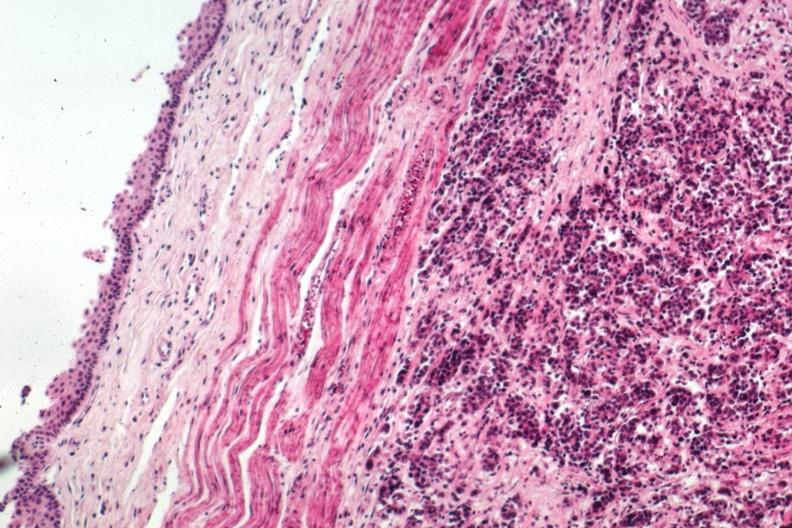what is present?
Answer the question using a single word or phrase. Gastrointestinal 